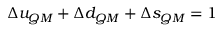Convert formula to latex. <formula><loc_0><loc_0><loc_500><loc_500>\Delta u _ { Q M } + \Delta d _ { Q M } + \Delta s _ { Q M } = 1</formula> 